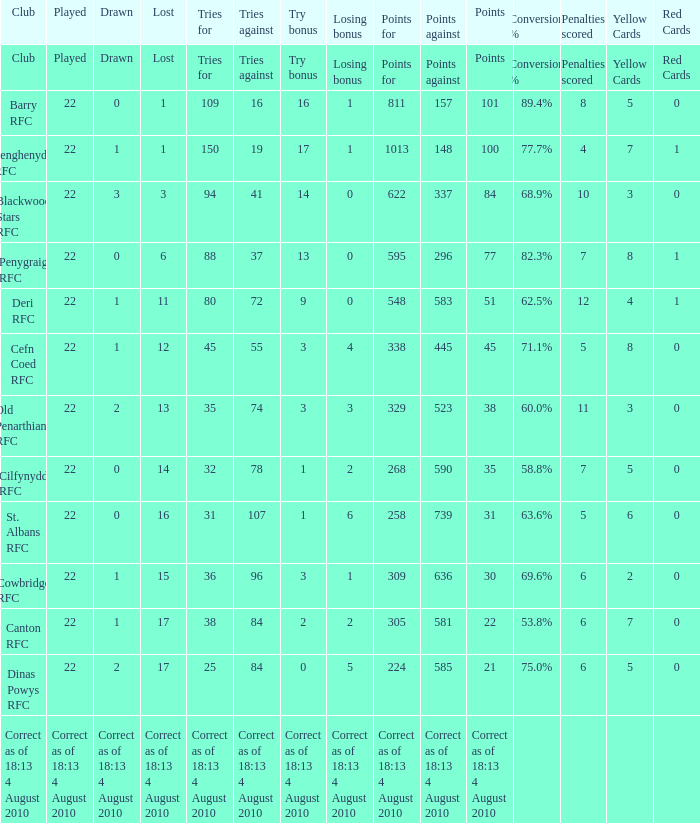I'm looking to parse the entire table for insights. Could you assist me with that? {'header': ['Club', 'Played', 'Drawn', 'Lost', 'Tries for', 'Tries against', 'Try bonus', 'Losing bonus', 'Points for', 'Points against', 'Points', 'Conversion %', 'Penalties scored', 'Yellow Cards', 'Red Cards '], 'rows': [['Club', 'Played', 'Drawn', 'Lost', 'Tries for', 'Tries against', 'Try bonus', 'Losing bonus', 'Points for', 'Points against', 'Points', 'Conversion %', 'Penalties scored', 'Yellow Cards', 'Red Cards '], ['Barry RFC', '22', '0', '1', '109', '16', '16', '1', '811', '157', '101', '89.4%', '8', '5', '0'], ['Senghenydd RFC', '22', '1', '1', '150', '19', '17', '1', '1013', '148', '100', '77.7%', '4', '7', '1'], ['Blackwood Stars RFC', '22', '3', '3', '94', '41', '14', '0', '622', '337', '84', '68.9%', '10', '3', '0'], ['Penygraig RFC', '22', '0', '6', '88', '37', '13', '0', '595', '296', '77', '82.3%', '7', '8', '1'], ['Deri RFC', '22', '1', '11', '80', '72', '9', '0', '548', '583', '51', '62.5%', '12', '4', '1'], ['Cefn Coed RFC', '22', '1', '12', '45', '55', '3', '4', '338', '445', '45', '71.1%', '5', '8', '0'], ['Old Penarthians RFC', '22', '2', '13', '35', '74', '3', '3', '329', '523', '38', '60.0%', '11', '3', '0'], ['Cilfynydd RFC', '22', '0', '14', '32', '78', '1', '2', '268', '590', '35', '58.8%', '7', '5', '0'], ['St. Albans RFC', '22', '0', '16', '31', '107', '1', '6', '258', '739', '31', '63.6%', '5', '6', '0'], ['Cowbridge RFC', '22', '1', '15', '36', '96', '3', '1', '309', '636', '30', '69.6%', '6', '2', '0'], ['Canton RFC', '22', '1', '17', '38', '84', '2', '2', '305', '581', '22', '53.8%', '6', '7', '0'], ['Dinas Powys RFC', '22', '2', '17', '25', '84', '0', '5', '224', '585', '21', '75.0%', '6', '5', '0'], ['Correct as of 18:13 4 August 2010', 'Correct as of 18:13 4 August 2010', 'Correct as of 18:13 4 August 2010', 'Correct as of 18:13 4 August 2010', 'Correct as of 18:13 4 August 2010', 'Correct as of 18:13 4 August 2010', 'Correct as of 18:13 4 August 2010', 'Correct as of 18:13 4 August 2010', 'Correct as of 18:13 4 August 2010', 'Correct as of 18:13 4 August 2010', 'Correct as of 18:13 4 August 2010', '', '', '', '']]} What is the name of the club when the played number is 22, and the try bonus was 0? Dinas Powys RFC. 